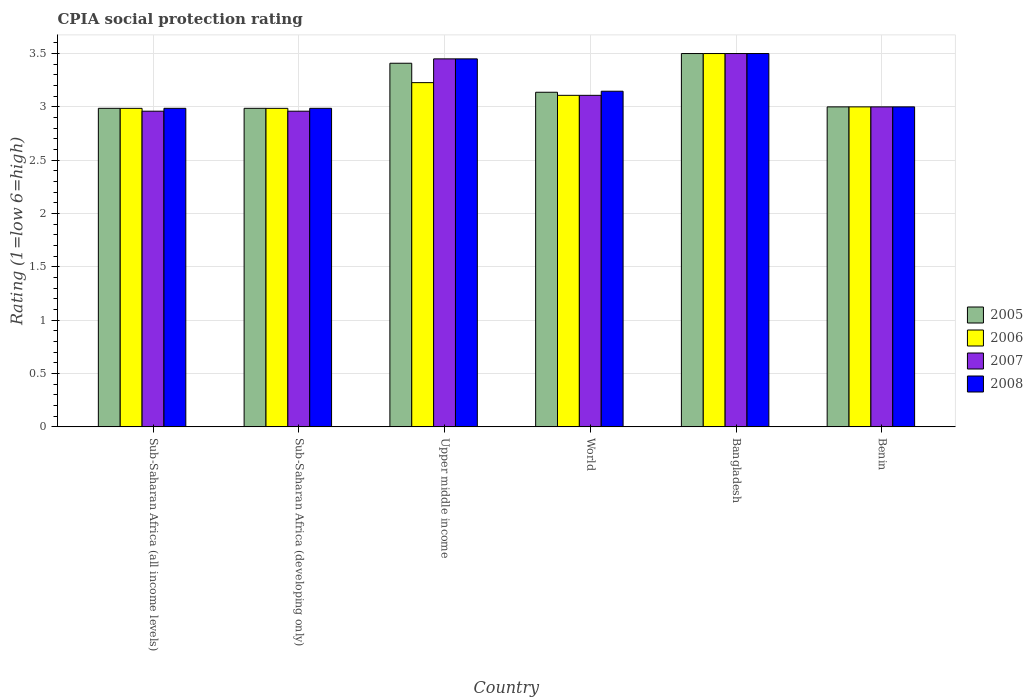How many different coloured bars are there?
Provide a succinct answer. 4. How many groups of bars are there?
Make the answer very short. 6. Are the number of bars per tick equal to the number of legend labels?
Make the answer very short. Yes. How many bars are there on the 2nd tick from the left?
Ensure brevity in your answer.  4. What is the label of the 5th group of bars from the left?
Offer a very short reply. Bangladesh. In how many cases, is the number of bars for a given country not equal to the number of legend labels?
Make the answer very short. 0. What is the CPIA rating in 2005 in Sub-Saharan Africa (developing only)?
Provide a short and direct response. 2.99. Across all countries, what is the minimum CPIA rating in 2005?
Give a very brief answer. 2.99. In which country was the CPIA rating in 2005 minimum?
Your response must be concise. Sub-Saharan Africa (all income levels). What is the total CPIA rating in 2007 in the graph?
Provide a short and direct response. 18.98. What is the difference between the CPIA rating in 2007 in Benin and that in Upper middle income?
Make the answer very short. -0.45. What is the difference between the CPIA rating in 2007 in Upper middle income and the CPIA rating in 2006 in Sub-Saharan Africa (all income levels)?
Offer a very short reply. 0.46. What is the average CPIA rating in 2008 per country?
Provide a succinct answer. 3.18. What is the difference between the CPIA rating of/in 2007 and CPIA rating of/in 2006 in Sub-Saharan Africa (developing only)?
Your answer should be compact. -0.03. What is the ratio of the CPIA rating in 2008 in Benin to that in Upper middle income?
Your response must be concise. 0.87. What is the difference between the highest and the second highest CPIA rating in 2008?
Make the answer very short. -0.05. What is the difference between the highest and the lowest CPIA rating in 2008?
Provide a short and direct response. 0.51. Is it the case that in every country, the sum of the CPIA rating in 2005 and CPIA rating in 2007 is greater than the sum of CPIA rating in 2008 and CPIA rating in 2006?
Offer a very short reply. No. What does the 2nd bar from the right in Upper middle income represents?
Make the answer very short. 2007. How many bars are there?
Give a very brief answer. 24. Are all the bars in the graph horizontal?
Make the answer very short. No. What is the difference between two consecutive major ticks on the Y-axis?
Offer a very short reply. 0.5. Does the graph contain any zero values?
Ensure brevity in your answer.  No. What is the title of the graph?
Offer a terse response. CPIA social protection rating. What is the Rating (1=low 6=high) in 2005 in Sub-Saharan Africa (all income levels)?
Offer a terse response. 2.99. What is the Rating (1=low 6=high) in 2006 in Sub-Saharan Africa (all income levels)?
Provide a succinct answer. 2.99. What is the Rating (1=low 6=high) in 2007 in Sub-Saharan Africa (all income levels)?
Your response must be concise. 2.96. What is the Rating (1=low 6=high) in 2008 in Sub-Saharan Africa (all income levels)?
Your answer should be very brief. 2.99. What is the Rating (1=low 6=high) in 2005 in Sub-Saharan Africa (developing only)?
Provide a short and direct response. 2.99. What is the Rating (1=low 6=high) of 2006 in Sub-Saharan Africa (developing only)?
Offer a terse response. 2.99. What is the Rating (1=low 6=high) of 2007 in Sub-Saharan Africa (developing only)?
Offer a terse response. 2.96. What is the Rating (1=low 6=high) of 2008 in Sub-Saharan Africa (developing only)?
Provide a succinct answer. 2.99. What is the Rating (1=low 6=high) of 2005 in Upper middle income?
Give a very brief answer. 3.41. What is the Rating (1=low 6=high) in 2006 in Upper middle income?
Give a very brief answer. 3.23. What is the Rating (1=low 6=high) in 2007 in Upper middle income?
Keep it short and to the point. 3.45. What is the Rating (1=low 6=high) of 2008 in Upper middle income?
Ensure brevity in your answer.  3.45. What is the Rating (1=low 6=high) of 2005 in World?
Keep it short and to the point. 3.14. What is the Rating (1=low 6=high) in 2006 in World?
Give a very brief answer. 3.11. What is the Rating (1=low 6=high) in 2007 in World?
Provide a short and direct response. 3.11. What is the Rating (1=low 6=high) in 2008 in World?
Keep it short and to the point. 3.15. What is the Rating (1=low 6=high) of 2006 in Bangladesh?
Ensure brevity in your answer.  3.5. What is the Rating (1=low 6=high) in 2005 in Benin?
Make the answer very short. 3. What is the Rating (1=low 6=high) in 2006 in Benin?
Ensure brevity in your answer.  3. Across all countries, what is the maximum Rating (1=low 6=high) in 2006?
Your answer should be compact. 3.5. Across all countries, what is the minimum Rating (1=low 6=high) in 2005?
Offer a terse response. 2.99. Across all countries, what is the minimum Rating (1=low 6=high) in 2006?
Your answer should be compact. 2.99. Across all countries, what is the minimum Rating (1=low 6=high) in 2007?
Offer a terse response. 2.96. Across all countries, what is the minimum Rating (1=low 6=high) in 2008?
Provide a short and direct response. 2.99. What is the total Rating (1=low 6=high) in 2005 in the graph?
Your response must be concise. 19.02. What is the total Rating (1=low 6=high) of 2006 in the graph?
Your answer should be compact. 18.81. What is the total Rating (1=low 6=high) in 2007 in the graph?
Provide a succinct answer. 18.98. What is the total Rating (1=low 6=high) in 2008 in the graph?
Make the answer very short. 19.07. What is the difference between the Rating (1=low 6=high) of 2005 in Sub-Saharan Africa (all income levels) and that in Sub-Saharan Africa (developing only)?
Give a very brief answer. 0. What is the difference between the Rating (1=low 6=high) of 2007 in Sub-Saharan Africa (all income levels) and that in Sub-Saharan Africa (developing only)?
Ensure brevity in your answer.  0. What is the difference between the Rating (1=low 6=high) of 2008 in Sub-Saharan Africa (all income levels) and that in Sub-Saharan Africa (developing only)?
Your response must be concise. 0. What is the difference between the Rating (1=low 6=high) in 2005 in Sub-Saharan Africa (all income levels) and that in Upper middle income?
Keep it short and to the point. -0.42. What is the difference between the Rating (1=low 6=high) in 2006 in Sub-Saharan Africa (all income levels) and that in Upper middle income?
Your answer should be compact. -0.24. What is the difference between the Rating (1=low 6=high) in 2007 in Sub-Saharan Africa (all income levels) and that in Upper middle income?
Give a very brief answer. -0.49. What is the difference between the Rating (1=low 6=high) of 2008 in Sub-Saharan Africa (all income levels) and that in Upper middle income?
Your answer should be very brief. -0.46. What is the difference between the Rating (1=low 6=high) of 2005 in Sub-Saharan Africa (all income levels) and that in World?
Your answer should be compact. -0.15. What is the difference between the Rating (1=low 6=high) in 2006 in Sub-Saharan Africa (all income levels) and that in World?
Your answer should be very brief. -0.12. What is the difference between the Rating (1=low 6=high) of 2007 in Sub-Saharan Africa (all income levels) and that in World?
Offer a terse response. -0.15. What is the difference between the Rating (1=low 6=high) in 2008 in Sub-Saharan Africa (all income levels) and that in World?
Provide a short and direct response. -0.16. What is the difference between the Rating (1=low 6=high) of 2005 in Sub-Saharan Africa (all income levels) and that in Bangladesh?
Make the answer very short. -0.51. What is the difference between the Rating (1=low 6=high) in 2006 in Sub-Saharan Africa (all income levels) and that in Bangladesh?
Make the answer very short. -0.51. What is the difference between the Rating (1=low 6=high) of 2007 in Sub-Saharan Africa (all income levels) and that in Bangladesh?
Your response must be concise. -0.54. What is the difference between the Rating (1=low 6=high) in 2008 in Sub-Saharan Africa (all income levels) and that in Bangladesh?
Provide a short and direct response. -0.51. What is the difference between the Rating (1=low 6=high) of 2005 in Sub-Saharan Africa (all income levels) and that in Benin?
Provide a short and direct response. -0.01. What is the difference between the Rating (1=low 6=high) of 2006 in Sub-Saharan Africa (all income levels) and that in Benin?
Your answer should be compact. -0.01. What is the difference between the Rating (1=low 6=high) in 2007 in Sub-Saharan Africa (all income levels) and that in Benin?
Your response must be concise. -0.04. What is the difference between the Rating (1=low 6=high) in 2008 in Sub-Saharan Africa (all income levels) and that in Benin?
Keep it short and to the point. -0.01. What is the difference between the Rating (1=low 6=high) of 2005 in Sub-Saharan Africa (developing only) and that in Upper middle income?
Your answer should be compact. -0.42. What is the difference between the Rating (1=low 6=high) of 2006 in Sub-Saharan Africa (developing only) and that in Upper middle income?
Provide a short and direct response. -0.24. What is the difference between the Rating (1=low 6=high) in 2007 in Sub-Saharan Africa (developing only) and that in Upper middle income?
Offer a terse response. -0.49. What is the difference between the Rating (1=low 6=high) in 2008 in Sub-Saharan Africa (developing only) and that in Upper middle income?
Offer a terse response. -0.46. What is the difference between the Rating (1=low 6=high) of 2005 in Sub-Saharan Africa (developing only) and that in World?
Your answer should be compact. -0.15. What is the difference between the Rating (1=low 6=high) in 2006 in Sub-Saharan Africa (developing only) and that in World?
Make the answer very short. -0.12. What is the difference between the Rating (1=low 6=high) of 2007 in Sub-Saharan Africa (developing only) and that in World?
Your answer should be compact. -0.15. What is the difference between the Rating (1=low 6=high) in 2008 in Sub-Saharan Africa (developing only) and that in World?
Provide a succinct answer. -0.16. What is the difference between the Rating (1=low 6=high) of 2005 in Sub-Saharan Africa (developing only) and that in Bangladesh?
Offer a very short reply. -0.51. What is the difference between the Rating (1=low 6=high) of 2006 in Sub-Saharan Africa (developing only) and that in Bangladesh?
Give a very brief answer. -0.51. What is the difference between the Rating (1=low 6=high) of 2007 in Sub-Saharan Africa (developing only) and that in Bangladesh?
Keep it short and to the point. -0.54. What is the difference between the Rating (1=low 6=high) of 2008 in Sub-Saharan Africa (developing only) and that in Bangladesh?
Your response must be concise. -0.51. What is the difference between the Rating (1=low 6=high) of 2005 in Sub-Saharan Africa (developing only) and that in Benin?
Make the answer very short. -0.01. What is the difference between the Rating (1=low 6=high) of 2006 in Sub-Saharan Africa (developing only) and that in Benin?
Your response must be concise. -0.01. What is the difference between the Rating (1=low 6=high) of 2007 in Sub-Saharan Africa (developing only) and that in Benin?
Offer a very short reply. -0.04. What is the difference between the Rating (1=low 6=high) in 2008 in Sub-Saharan Africa (developing only) and that in Benin?
Offer a very short reply. -0.01. What is the difference between the Rating (1=low 6=high) in 2005 in Upper middle income and that in World?
Make the answer very short. 0.27. What is the difference between the Rating (1=low 6=high) in 2006 in Upper middle income and that in World?
Give a very brief answer. 0.12. What is the difference between the Rating (1=low 6=high) of 2007 in Upper middle income and that in World?
Make the answer very short. 0.34. What is the difference between the Rating (1=low 6=high) in 2008 in Upper middle income and that in World?
Offer a very short reply. 0.3. What is the difference between the Rating (1=low 6=high) of 2005 in Upper middle income and that in Bangladesh?
Offer a terse response. -0.09. What is the difference between the Rating (1=low 6=high) of 2006 in Upper middle income and that in Bangladesh?
Ensure brevity in your answer.  -0.27. What is the difference between the Rating (1=low 6=high) of 2007 in Upper middle income and that in Bangladesh?
Keep it short and to the point. -0.05. What is the difference between the Rating (1=low 6=high) of 2005 in Upper middle income and that in Benin?
Provide a succinct answer. 0.41. What is the difference between the Rating (1=low 6=high) in 2006 in Upper middle income and that in Benin?
Make the answer very short. 0.23. What is the difference between the Rating (1=low 6=high) of 2007 in Upper middle income and that in Benin?
Provide a succinct answer. 0.45. What is the difference between the Rating (1=low 6=high) of 2008 in Upper middle income and that in Benin?
Provide a succinct answer. 0.45. What is the difference between the Rating (1=low 6=high) in 2005 in World and that in Bangladesh?
Keep it short and to the point. -0.36. What is the difference between the Rating (1=low 6=high) of 2006 in World and that in Bangladesh?
Give a very brief answer. -0.39. What is the difference between the Rating (1=low 6=high) in 2007 in World and that in Bangladesh?
Keep it short and to the point. -0.39. What is the difference between the Rating (1=low 6=high) of 2008 in World and that in Bangladesh?
Offer a very short reply. -0.35. What is the difference between the Rating (1=low 6=high) in 2005 in World and that in Benin?
Make the answer very short. 0.14. What is the difference between the Rating (1=low 6=high) in 2006 in World and that in Benin?
Make the answer very short. 0.11. What is the difference between the Rating (1=low 6=high) of 2007 in World and that in Benin?
Keep it short and to the point. 0.11. What is the difference between the Rating (1=low 6=high) of 2008 in World and that in Benin?
Ensure brevity in your answer.  0.15. What is the difference between the Rating (1=low 6=high) in 2006 in Bangladesh and that in Benin?
Provide a succinct answer. 0.5. What is the difference between the Rating (1=low 6=high) of 2008 in Bangladesh and that in Benin?
Provide a short and direct response. 0.5. What is the difference between the Rating (1=low 6=high) of 2005 in Sub-Saharan Africa (all income levels) and the Rating (1=low 6=high) of 2007 in Sub-Saharan Africa (developing only)?
Offer a very short reply. 0.03. What is the difference between the Rating (1=low 6=high) in 2005 in Sub-Saharan Africa (all income levels) and the Rating (1=low 6=high) in 2008 in Sub-Saharan Africa (developing only)?
Your response must be concise. 0. What is the difference between the Rating (1=low 6=high) of 2006 in Sub-Saharan Africa (all income levels) and the Rating (1=low 6=high) of 2007 in Sub-Saharan Africa (developing only)?
Keep it short and to the point. 0.03. What is the difference between the Rating (1=low 6=high) in 2006 in Sub-Saharan Africa (all income levels) and the Rating (1=low 6=high) in 2008 in Sub-Saharan Africa (developing only)?
Make the answer very short. -0. What is the difference between the Rating (1=low 6=high) in 2007 in Sub-Saharan Africa (all income levels) and the Rating (1=low 6=high) in 2008 in Sub-Saharan Africa (developing only)?
Keep it short and to the point. -0.03. What is the difference between the Rating (1=low 6=high) of 2005 in Sub-Saharan Africa (all income levels) and the Rating (1=low 6=high) of 2006 in Upper middle income?
Offer a very short reply. -0.24. What is the difference between the Rating (1=low 6=high) of 2005 in Sub-Saharan Africa (all income levels) and the Rating (1=low 6=high) of 2007 in Upper middle income?
Make the answer very short. -0.46. What is the difference between the Rating (1=low 6=high) of 2005 in Sub-Saharan Africa (all income levels) and the Rating (1=low 6=high) of 2008 in Upper middle income?
Give a very brief answer. -0.46. What is the difference between the Rating (1=low 6=high) of 2006 in Sub-Saharan Africa (all income levels) and the Rating (1=low 6=high) of 2007 in Upper middle income?
Provide a succinct answer. -0.46. What is the difference between the Rating (1=low 6=high) of 2006 in Sub-Saharan Africa (all income levels) and the Rating (1=low 6=high) of 2008 in Upper middle income?
Offer a very short reply. -0.46. What is the difference between the Rating (1=low 6=high) in 2007 in Sub-Saharan Africa (all income levels) and the Rating (1=low 6=high) in 2008 in Upper middle income?
Keep it short and to the point. -0.49. What is the difference between the Rating (1=low 6=high) of 2005 in Sub-Saharan Africa (all income levels) and the Rating (1=low 6=high) of 2006 in World?
Your answer should be compact. -0.12. What is the difference between the Rating (1=low 6=high) in 2005 in Sub-Saharan Africa (all income levels) and the Rating (1=low 6=high) in 2007 in World?
Your answer should be compact. -0.12. What is the difference between the Rating (1=low 6=high) of 2005 in Sub-Saharan Africa (all income levels) and the Rating (1=low 6=high) of 2008 in World?
Your answer should be compact. -0.16. What is the difference between the Rating (1=low 6=high) in 2006 in Sub-Saharan Africa (all income levels) and the Rating (1=low 6=high) in 2007 in World?
Make the answer very short. -0.12. What is the difference between the Rating (1=low 6=high) of 2006 in Sub-Saharan Africa (all income levels) and the Rating (1=low 6=high) of 2008 in World?
Provide a short and direct response. -0.16. What is the difference between the Rating (1=low 6=high) of 2007 in Sub-Saharan Africa (all income levels) and the Rating (1=low 6=high) of 2008 in World?
Give a very brief answer. -0.19. What is the difference between the Rating (1=low 6=high) of 2005 in Sub-Saharan Africa (all income levels) and the Rating (1=low 6=high) of 2006 in Bangladesh?
Ensure brevity in your answer.  -0.51. What is the difference between the Rating (1=low 6=high) in 2005 in Sub-Saharan Africa (all income levels) and the Rating (1=low 6=high) in 2007 in Bangladesh?
Give a very brief answer. -0.51. What is the difference between the Rating (1=low 6=high) of 2005 in Sub-Saharan Africa (all income levels) and the Rating (1=low 6=high) of 2008 in Bangladesh?
Ensure brevity in your answer.  -0.51. What is the difference between the Rating (1=low 6=high) in 2006 in Sub-Saharan Africa (all income levels) and the Rating (1=low 6=high) in 2007 in Bangladesh?
Provide a short and direct response. -0.51. What is the difference between the Rating (1=low 6=high) in 2006 in Sub-Saharan Africa (all income levels) and the Rating (1=low 6=high) in 2008 in Bangladesh?
Your response must be concise. -0.51. What is the difference between the Rating (1=low 6=high) in 2007 in Sub-Saharan Africa (all income levels) and the Rating (1=low 6=high) in 2008 in Bangladesh?
Offer a very short reply. -0.54. What is the difference between the Rating (1=low 6=high) in 2005 in Sub-Saharan Africa (all income levels) and the Rating (1=low 6=high) in 2006 in Benin?
Ensure brevity in your answer.  -0.01. What is the difference between the Rating (1=low 6=high) in 2005 in Sub-Saharan Africa (all income levels) and the Rating (1=low 6=high) in 2007 in Benin?
Your answer should be very brief. -0.01. What is the difference between the Rating (1=low 6=high) in 2005 in Sub-Saharan Africa (all income levels) and the Rating (1=low 6=high) in 2008 in Benin?
Offer a very short reply. -0.01. What is the difference between the Rating (1=low 6=high) in 2006 in Sub-Saharan Africa (all income levels) and the Rating (1=low 6=high) in 2007 in Benin?
Make the answer very short. -0.01. What is the difference between the Rating (1=low 6=high) in 2006 in Sub-Saharan Africa (all income levels) and the Rating (1=low 6=high) in 2008 in Benin?
Your answer should be compact. -0.01. What is the difference between the Rating (1=low 6=high) of 2007 in Sub-Saharan Africa (all income levels) and the Rating (1=low 6=high) of 2008 in Benin?
Provide a short and direct response. -0.04. What is the difference between the Rating (1=low 6=high) in 2005 in Sub-Saharan Africa (developing only) and the Rating (1=low 6=high) in 2006 in Upper middle income?
Your answer should be very brief. -0.24. What is the difference between the Rating (1=low 6=high) of 2005 in Sub-Saharan Africa (developing only) and the Rating (1=low 6=high) of 2007 in Upper middle income?
Ensure brevity in your answer.  -0.46. What is the difference between the Rating (1=low 6=high) in 2005 in Sub-Saharan Africa (developing only) and the Rating (1=low 6=high) in 2008 in Upper middle income?
Your answer should be very brief. -0.46. What is the difference between the Rating (1=low 6=high) of 2006 in Sub-Saharan Africa (developing only) and the Rating (1=low 6=high) of 2007 in Upper middle income?
Offer a very short reply. -0.46. What is the difference between the Rating (1=low 6=high) of 2006 in Sub-Saharan Africa (developing only) and the Rating (1=low 6=high) of 2008 in Upper middle income?
Provide a succinct answer. -0.46. What is the difference between the Rating (1=low 6=high) of 2007 in Sub-Saharan Africa (developing only) and the Rating (1=low 6=high) of 2008 in Upper middle income?
Offer a terse response. -0.49. What is the difference between the Rating (1=low 6=high) in 2005 in Sub-Saharan Africa (developing only) and the Rating (1=low 6=high) in 2006 in World?
Offer a terse response. -0.12. What is the difference between the Rating (1=low 6=high) of 2005 in Sub-Saharan Africa (developing only) and the Rating (1=low 6=high) of 2007 in World?
Your response must be concise. -0.12. What is the difference between the Rating (1=low 6=high) in 2005 in Sub-Saharan Africa (developing only) and the Rating (1=low 6=high) in 2008 in World?
Provide a short and direct response. -0.16. What is the difference between the Rating (1=low 6=high) of 2006 in Sub-Saharan Africa (developing only) and the Rating (1=low 6=high) of 2007 in World?
Your answer should be very brief. -0.12. What is the difference between the Rating (1=low 6=high) in 2006 in Sub-Saharan Africa (developing only) and the Rating (1=low 6=high) in 2008 in World?
Ensure brevity in your answer.  -0.16. What is the difference between the Rating (1=low 6=high) of 2007 in Sub-Saharan Africa (developing only) and the Rating (1=low 6=high) of 2008 in World?
Your response must be concise. -0.19. What is the difference between the Rating (1=low 6=high) of 2005 in Sub-Saharan Africa (developing only) and the Rating (1=low 6=high) of 2006 in Bangladesh?
Your response must be concise. -0.51. What is the difference between the Rating (1=low 6=high) of 2005 in Sub-Saharan Africa (developing only) and the Rating (1=low 6=high) of 2007 in Bangladesh?
Your answer should be compact. -0.51. What is the difference between the Rating (1=low 6=high) in 2005 in Sub-Saharan Africa (developing only) and the Rating (1=low 6=high) in 2008 in Bangladesh?
Offer a terse response. -0.51. What is the difference between the Rating (1=low 6=high) of 2006 in Sub-Saharan Africa (developing only) and the Rating (1=low 6=high) of 2007 in Bangladesh?
Give a very brief answer. -0.51. What is the difference between the Rating (1=low 6=high) of 2006 in Sub-Saharan Africa (developing only) and the Rating (1=low 6=high) of 2008 in Bangladesh?
Your response must be concise. -0.51. What is the difference between the Rating (1=low 6=high) of 2007 in Sub-Saharan Africa (developing only) and the Rating (1=low 6=high) of 2008 in Bangladesh?
Offer a terse response. -0.54. What is the difference between the Rating (1=low 6=high) of 2005 in Sub-Saharan Africa (developing only) and the Rating (1=low 6=high) of 2006 in Benin?
Offer a very short reply. -0.01. What is the difference between the Rating (1=low 6=high) of 2005 in Sub-Saharan Africa (developing only) and the Rating (1=low 6=high) of 2007 in Benin?
Provide a succinct answer. -0.01. What is the difference between the Rating (1=low 6=high) in 2005 in Sub-Saharan Africa (developing only) and the Rating (1=low 6=high) in 2008 in Benin?
Provide a succinct answer. -0.01. What is the difference between the Rating (1=low 6=high) in 2006 in Sub-Saharan Africa (developing only) and the Rating (1=low 6=high) in 2007 in Benin?
Make the answer very short. -0.01. What is the difference between the Rating (1=low 6=high) in 2006 in Sub-Saharan Africa (developing only) and the Rating (1=low 6=high) in 2008 in Benin?
Ensure brevity in your answer.  -0.01. What is the difference between the Rating (1=low 6=high) in 2007 in Sub-Saharan Africa (developing only) and the Rating (1=low 6=high) in 2008 in Benin?
Your answer should be compact. -0.04. What is the difference between the Rating (1=low 6=high) of 2005 in Upper middle income and the Rating (1=low 6=high) of 2006 in World?
Your answer should be very brief. 0.3. What is the difference between the Rating (1=low 6=high) in 2005 in Upper middle income and the Rating (1=low 6=high) in 2007 in World?
Keep it short and to the point. 0.3. What is the difference between the Rating (1=low 6=high) in 2005 in Upper middle income and the Rating (1=low 6=high) in 2008 in World?
Your answer should be compact. 0.26. What is the difference between the Rating (1=low 6=high) in 2006 in Upper middle income and the Rating (1=low 6=high) in 2007 in World?
Ensure brevity in your answer.  0.12. What is the difference between the Rating (1=low 6=high) of 2006 in Upper middle income and the Rating (1=low 6=high) of 2008 in World?
Your response must be concise. 0.08. What is the difference between the Rating (1=low 6=high) in 2007 in Upper middle income and the Rating (1=low 6=high) in 2008 in World?
Offer a terse response. 0.3. What is the difference between the Rating (1=low 6=high) in 2005 in Upper middle income and the Rating (1=low 6=high) in 2006 in Bangladesh?
Keep it short and to the point. -0.09. What is the difference between the Rating (1=low 6=high) of 2005 in Upper middle income and the Rating (1=low 6=high) of 2007 in Bangladesh?
Provide a short and direct response. -0.09. What is the difference between the Rating (1=low 6=high) of 2005 in Upper middle income and the Rating (1=low 6=high) of 2008 in Bangladesh?
Your response must be concise. -0.09. What is the difference between the Rating (1=low 6=high) in 2006 in Upper middle income and the Rating (1=low 6=high) in 2007 in Bangladesh?
Keep it short and to the point. -0.27. What is the difference between the Rating (1=low 6=high) of 2006 in Upper middle income and the Rating (1=low 6=high) of 2008 in Bangladesh?
Ensure brevity in your answer.  -0.27. What is the difference between the Rating (1=low 6=high) in 2007 in Upper middle income and the Rating (1=low 6=high) in 2008 in Bangladesh?
Your response must be concise. -0.05. What is the difference between the Rating (1=low 6=high) of 2005 in Upper middle income and the Rating (1=low 6=high) of 2006 in Benin?
Your answer should be very brief. 0.41. What is the difference between the Rating (1=low 6=high) of 2005 in Upper middle income and the Rating (1=low 6=high) of 2007 in Benin?
Make the answer very short. 0.41. What is the difference between the Rating (1=low 6=high) of 2005 in Upper middle income and the Rating (1=low 6=high) of 2008 in Benin?
Provide a succinct answer. 0.41. What is the difference between the Rating (1=low 6=high) in 2006 in Upper middle income and the Rating (1=low 6=high) in 2007 in Benin?
Make the answer very short. 0.23. What is the difference between the Rating (1=low 6=high) of 2006 in Upper middle income and the Rating (1=low 6=high) of 2008 in Benin?
Your answer should be very brief. 0.23. What is the difference between the Rating (1=low 6=high) of 2007 in Upper middle income and the Rating (1=low 6=high) of 2008 in Benin?
Offer a terse response. 0.45. What is the difference between the Rating (1=low 6=high) of 2005 in World and the Rating (1=low 6=high) of 2006 in Bangladesh?
Provide a short and direct response. -0.36. What is the difference between the Rating (1=low 6=high) in 2005 in World and the Rating (1=low 6=high) in 2007 in Bangladesh?
Your response must be concise. -0.36. What is the difference between the Rating (1=low 6=high) of 2005 in World and the Rating (1=low 6=high) of 2008 in Bangladesh?
Provide a succinct answer. -0.36. What is the difference between the Rating (1=low 6=high) in 2006 in World and the Rating (1=low 6=high) in 2007 in Bangladesh?
Your answer should be compact. -0.39. What is the difference between the Rating (1=low 6=high) of 2006 in World and the Rating (1=low 6=high) of 2008 in Bangladesh?
Your answer should be compact. -0.39. What is the difference between the Rating (1=low 6=high) in 2007 in World and the Rating (1=low 6=high) in 2008 in Bangladesh?
Give a very brief answer. -0.39. What is the difference between the Rating (1=low 6=high) of 2005 in World and the Rating (1=low 6=high) of 2006 in Benin?
Your answer should be very brief. 0.14. What is the difference between the Rating (1=low 6=high) of 2005 in World and the Rating (1=low 6=high) of 2007 in Benin?
Ensure brevity in your answer.  0.14. What is the difference between the Rating (1=low 6=high) in 2005 in World and the Rating (1=low 6=high) in 2008 in Benin?
Provide a succinct answer. 0.14. What is the difference between the Rating (1=low 6=high) of 2006 in World and the Rating (1=low 6=high) of 2007 in Benin?
Give a very brief answer. 0.11. What is the difference between the Rating (1=low 6=high) in 2006 in World and the Rating (1=low 6=high) in 2008 in Benin?
Keep it short and to the point. 0.11. What is the difference between the Rating (1=low 6=high) in 2007 in World and the Rating (1=low 6=high) in 2008 in Benin?
Give a very brief answer. 0.11. What is the difference between the Rating (1=low 6=high) in 2005 in Bangladesh and the Rating (1=low 6=high) in 2006 in Benin?
Your answer should be compact. 0.5. What is the difference between the Rating (1=low 6=high) in 2006 in Bangladesh and the Rating (1=low 6=high) in 2007 in Benin?
Keep it short and to the point. 0.5. What is the average Rating (1=low 6=high) in 2005 per country?
Make the answer very short. 3.17. What is the average Rating (1=low 6=high) of 2006 per country?
Make the answer very short. 3.13. What is the average Rating (1=low 6=high) in 2007 per country?
Ensure brevity in your answer.  3.16. What is the average Rating (1=low 6=high) of 2008 per country?
Your answer should be very brief. 3.18. What is the difference between the Rating (1=low 6=high) of 2005 and Rating (1=low 6=high) of 2006 in Sub-Saharan Africa (all income levels)?
Offer a terse response. 0. What is the difference between the Rating (1=low 6=high) of 2005 and Rating (1=low 6=high) of 2007 in Sub-Saharan Africa (all income levels)?
Give a very brief answer. 0.03. What is the difference between the Rating (1=low 6=high) in 2006 and Rating (1=low 6=high) in 2007 in Sub-Saharan Africa (all income levels)?
Your response must be concise. 0.03. What is the difference between the Rating (1=low 6=high) of 2006 and Rating (1=low 6=high) of 2008 in Sub-Saharan Africa (all income levels)?
Provide a succinct answer. -0. What is the difference between the Rating (1=low 6=high) in 2007 and Rating (1=low 6=high) in 2008 in Sub-Saharan Africa (all income levels)?
Make the answer very short. -0.03. What is the difference between the Rating (1=low 6=high) in 2005 and Rating (1=low 6=high) in 2007 in Sub-Saharan Africa (developing only)?
Provide a short and direct response. 0.03. What is the difference between the Rating (1=low 6=high) in 2006 and Rating (1=low 6=high) in 2007 in Sub-Saharan Africa (developing only)?
Offer a very short reply. 0.03. What is the difference between the Rating (1=low 6=high) of 2006 and Rating (1=low 6=high) of 2008 in Sub-Saharan Africa (developing only)?
Keep it short and to the point. -0. What is the difference between the Rating (1=low 6=high) of 2007 and Rating (1=low 6=high) of 2008 in Sub-Saharan Africa (developing only)?
Give a very brief answer. -0.03. What is the difference between the Rating (1=low 6=high) in 2005 and Rating (1=low 6=high) in 2006 in Upper middle income?
Provide a short and direct response. 0.18. What is the difference between the Rating (1=low 6=high) in 2005 and Rating (1=low 6=high) in 2007 in Upper middle income?
Your answer should be compact. -0.04. What is the difference between the Rating (1=low 6=high) of 2005 and Rating (1=low 6=high) of 2008 in Upper middle income?
Provide a succinct answer. -0.04. What is the difference between the Rating (1=low 6=high) of 2006 and Rating (1=low 6=high) of 2007 in Upper middle income?
Your answer should be compact. -0.22. What is the difference between the Rating (1=low 6=high) in 2006 and Rating (1=low 6=high) in 2008 in Upper middle income?
Ensure brevity in your answer.  -0.22. What is the difference between the Rating (1=low 6=high) in 2007 and Rating (1=low 6=high) in 2008 in Upper middle income?
Your answer should be very brief. 0. What is the difference between the Rating (1=low 6=high) of 2005 and Rating (1=low 6=high) of 2006 in World?
Your answer should be very brief. 0.03. What is the difference between the Rating (1=low 6=high) of 2005 and Rating (1=low 6=high) of 2007 in World?
Make the answer very short. 0.03. What is the difference between the Rating (1=low 6=high) of 2005 and Rating (1=low 6=high) of 2008 in World?
Offer a very short reply. -0.01. What is the difference between the Rating (1=low 6=high) of 2006 and Rating (1=low 6=high) of 2008 in World?
Ensure brevity in your answer.  -0.04. What is the difference between the Rating (1=low 6=high) in 2007 and Rating (1=low 6=high) in 2008 in World?
Make the answer very short. -0.04. What is the difference between the Rating (1=low 6=high) in 2005 and Rating (1=low 6=high) in 2006 in Bangladesh?
Offer a very short reply. 0. What is the difference between the Rating (1=low 6=high) of 2005 and Rating (1=low 6=high) of 2007 in Bangladesh?
Your response must be concise. 0. What is the difference between the Rating (1=low 6=high) in 2006 and Rating (1=low 6=high) in 2008 in Bangladesh?
Your response must be concise. 0. What is the difference between the Rating (1=low 6=high) of 2007 and Rating (1=low 6=high) of 2008 in Bangladesh?
Provide a short and direct response. 0. What is the difference between the Rating (1=low 6=high) of 2005 and Rating (1=low 6=high) of 2006 in Benin?
Ensure brevity in your answer.  0. What is the difference between the Rating (1=low 6=high) of 2005 and Rating (1=low 6=high) of 2007 in Benin?
Make the answer very short. 0. What is the difference between the Rating (1=low 6=high) of 2006 and Rating (1=low 6=high) of 2007 in Benin?
Your answer should be very brief. 0. What is the ratio of the Rating (1=low 6=high) of 2005 in Sub-Saharan Africa (all income levels) to that in Sub-Saharan Africa (developing only)?
Ensure brevity in your answer.  1. What is the ratio of the Rating (1=low 6=high) in 2007 in Sub-Saharan Africa (all income levels) to that in Sub-Saharan Africa (developing only)?
Ensure brevity in your answer.  1. What is the ratio of the Rating (1=low 6=high) in 2008 in Sub-Saharan Africa (all income levels) to that in Sub-Saharan Africa (developing only)?
Your answer should be very brief. 1. What is the ratio of the Rating (1=low 6=high) of 2005 in Sub-Saharan Africa (all income levels) to that in Upper middle income?
Your response must be concise. 0.88. What is the ratio of the Rating (1=low 6=high) of 2006 in Sub-Saharan Africa (all income levels) to that in Upper middle income?
Provide a short and direct response. 0.93. What is the ratio of the Rating (1=low 6=high) of 2007 in Sub-Saharan Africa (all income levels) to that in Upper middle income?
Offer a very short reply. 0.86. What is the ratio of the Rating (1=low 6=high) of 2008 in Sub-Saharan Africa (all income levels) to that in Upper middle income?
Your answer should be very brief. 0.87. What is the ratio of the Rating (1=low 6=high) of 2006 in Sub-Saharan Africa (all income levels) to that in World?
Make the answer very short. 0.96. What is the ratio of the Rating (1=low 6=high) of 2007 in Sub-Saharan Africa (all income levels) to that in World?
Your response must be concise. 0.95. What is the ratio of the Rating (1=low 6=high) in 2008 in Sub-Saharan Africa (all income levels) to that in World?
Your answer should be compact. 0.95. What is the ratio of the Rating (1=low 6=high) of 2005 in Sub-Saharan Africa (all income levels) to that in Bangladesh?
Your answer should be compact. 0.85. What is the ratio of the Rating (1=low 6=high) in 2006 in Sub-Saharan Africa (all income levels) to that in Bangladesh?
Ensure brevity in your answer.  0.85. What is the ratio of the Rating (1=low 6=high) in 2007 in Sub-Saharan Africa (all income levels) to that in Bangladesh?
Give a very brief answer. 0.85. What is the ratio of the Rating (1=low 6=high) of 2008 in Sub-Saharan Africa (all income levels) to that in Bangladesh?
Offer a terse response. 0.85. What is the ratio of the Rating (1=low 6=high) in 2007 in Sub-Saharan Africa (all income levels) to that in Benin?
Provide a succinct answer. 0.99. What is the ratio of the Rating (1=low 6=high) in 2005 in Sub-Saharan Africa (developing only) to that in Upper middle income?
Provide a short and direct response. 0.88. What is the ratio of the Rating (1=low 6=high) of 2006 in Sub-Saharan Africa (developing only) to that in Upper middle income?
Keep it short and to the point. 0.93. What is the ratio of the Rating (1=low 6=high) of 2007 in Sub-Saharan Africa (developing only) to that in Upper middle income?
Offer a terse response. 0.86. What is the ratio of the Rating (1=low 6=high) of 2008 in Sub-Saharan Africa (developing only) to that in Upper middle income?
Provide a succinct answer. 0.87. What is the ratio of the Rating (1=low 6=high) in 2005 in Sub-Saharan Africa (developing only) to that in World?
Make the answer very short. 0.95. What is the ratio of the Rating (1=low 6=high) of 2006 in Sub-Saharan Africa (developing only) to that in World?
Give a very brief answer. 0.96. What is the ratio of the Rating (1=low 6=high) of 2007 in Sub-Saharan Africa (developing only) to that in World?
Ensure brevity in your answer.  0.95. What is the ratio of the Rating (1=low 6=high) of 2008 in Sub-Saharan Africa (developing only) to that in World?
Provide a succinct answer. 0.95. What is the ratio of the Rating (1=low 6=high) in 2005 in Sub-Saharan Africa (developing only) to that in Bangladesh?
Give a very brief answer. 0.85. What is the ratio of the Rating (1=low 6=high) in 2006 in Sub-Saharan Africa (developing only) to that in Bangladesh?
Provide a succinct answer. 0.85. What is the ratio of the Rating (1=low 6=high) of 2007 in Sub-Saharan Africa (developing only) to that in Bangladesh?
Your answer should be very brief. 0.85. What is the ratio of the Rating (1=low 6=high) in 2008 in Sub-Saharan Africa (developing only) to that in Bangladesh?
Make the answer very short. 0.85. What is the ratio of the Rating (1=low 6=high) in 2005 in Sub-Saharan Africa (developing only) to that in Benin?
Your answer should be very brief. 1. What is the ratio of the Rating (1=low 6=high) of 2007 in Sub-Saharan Africa (developing only) to that in Benin?
Offer a terse response. 0.99. What is the ratio of the Rating (1=low 6=high) of 2005 in Upper middle income to that in World?
Ensure brevity in your answer.  1.09. What is the ratio of the Rating (1=low 6=high) of 2006 in Upper middle income to that in World?
Offer a terse response. 1.04. What is the ratio of the Rating (1=low 6=high) in 2007 in Upper middle income to that in World?
Your answer should be very brief. 1.11. What is the ratio of the Rating (1=low 6=high) in 2008 in Upper middle income to that in World?
Ensure brevity in your answer.  1.1. What is the ratio of the Rating (1=low 6=high) in 2005 in Upper middle income to that in Bangladesh?
Your answer should be compact. 0.97. What is the ratio of the Rating (1=low 6=high) in 2006 in Upper middle income to that in Bangladesh?
Your response must be concise. 0.92. What is the ratio of the Rating (1=low 6=high) in 2007 in Upper middle income to that in Bangladesh?
Keep it short and to the point. 0.99. What is the ratio of the Rating (1=low 6=high) in 2008 in Upper middle income to that in Bangladesh?
Offer a very short reply. 0.99. What is the ratio of the Rating (1=low 6=high) in 2005 in Upper middle income to that in Benin?
Make the answer very short. 1.14. What is the ratio of the Rating (1=low 6=high) of 2006 in Upper middle income to that in Benin?
Your answer should be compact. 1.08. What is the ratio of the Rating (1=low 6=high) of 2007 in Upper middle income to that in Benin?
Your response must be concise. 1.15. What is the ratio of the Rating (1=low 6=high) in 2008 in Upper middle income to that in Benin?
Your response must be concise. 1.15. What is the ratio of the Rating (1=low 6=high) of 2005 in World to that in Bangladesh?
Provide a succinct answer. 0.9. What is the ratio of the Rating (1=low 6=high) of 2006 in World to that in Bangladesh?
Keep it short and to the point. 0.89. What is the ratio of the Rating (1=low 6=high) in 2007 in World to that in Bangladesh?
Ensure brevity in your answer.  0.89. What is the ratio of the Rating (1=low 6=high) of 2008 in World to that in Bangladesh?
Your answer should be compact. 0.9. What is the ratio of the Rating (1=low 6=high) in 2005 in World to that in Benin?
Your answer should be compact. 1.05. What is the ratio of the Rating (1=low 6=high) of 2006 in World to that in Benin?
Ensure brevity in your answer.  1.04. What is the ratio of the Rating (1=low 6=high) in 2007 in World to that in Benin?
Offer a terse response. 1.04. What is the ratio of the Rating (1=low 6=high) in 2008 in World to that in Benin?
Provide a short and direct response. 1.05. What is the ratio of the Rating (1=low 6=high) in 2005 in Bangladesh to that in Benin?
Provide a short and direct response. 1.17. What is the difference between the highest and the second highest Rating (1=low 6=high) in 2005?
Provide a short and direct response. 0.09. What is the difference between the highest and the second highest Rating (1=low 6=high) in 2006?
Offer a terse response. 0.27. What is the difference between the highest and the lowest Rating (1=low 6=high) of 2005?
Offer a terse response. 0.51. What is the difference between the highest and the lowest Rating (1=low 6=high) of 2006?
Offer a terse response. 0.51. What is the difference between the highest and the lowest Rating (1=low 6=high) of 2007?
Ensure brevity in your answer.  0.54. What is the difference between the highest and the lowest Rating (1=low 6=high) of 2008?
Your answer should be very brief. 0.51. 